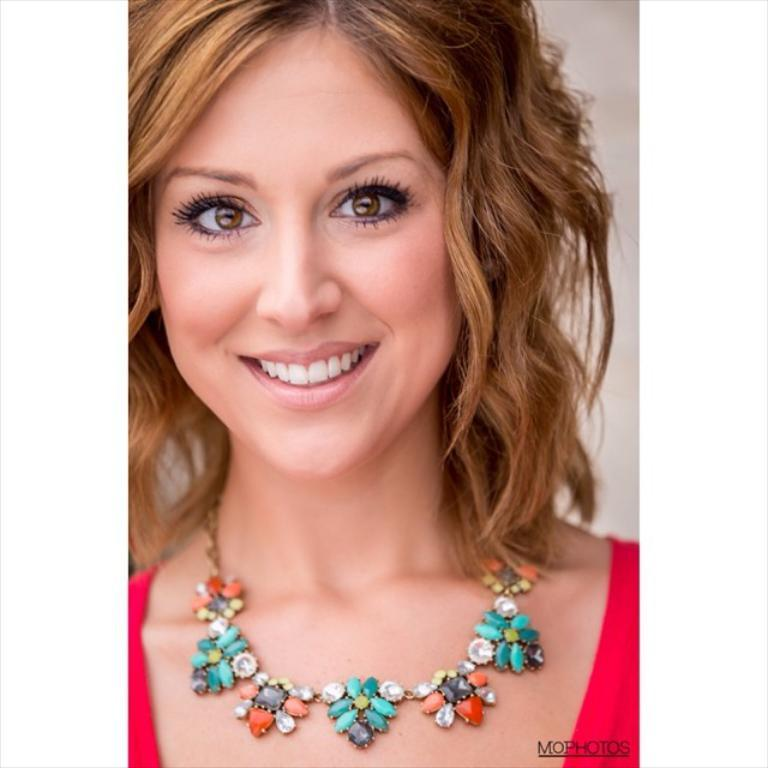Who is the main subject in the image? There is a woman in the image. What is the woman doing in the image? The woman is posing for a picture. What is the woman wearing in the image? The woman is wearing a red dress. Is there any text visible in the image? Yes, there is some text in the right bottom corner of the image. What type of fuel is being used by the woman in the image? There is no indication of any fuel being used in the image; the woman is simply posing for a picture. How much sugar is visible in the image? There is no sugar present in the image. 